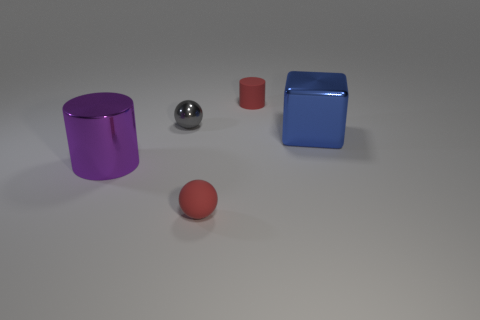Does the matte object behind the tiny red rubber ball have the same size as the red rubber object that is left of the small matte cylinder?
Keep it short and to the point. Yes. How many other things are the same color as the small matte cylinder?
Provide a succinct answer. 1. Does the metallic cube have the same size as the red matte thing that is in front of the purple cylinder?
Make the answer very short. No. What size is the red thing left of the red rubber thing that is behind the gray object?
Give a very brief answer. Small. There is another small rubber thing that is the same shape as the small gray thing; what is its color?
Your answer should be compact. Red. Does the gray object have the same size as the red cylinder?
Keep it short and to the point. Yes. Is the number of blue blocks to the right of the big cube the same as the number of rubber objects?
Offer a very short reply. No. There is a cylinder behind the large blue block; are there any small red rubber things behind it?
Your answer should be very brief. No. What size is the cylinder that is to the right of the small red object in front of the rubber object behind the big purple thing?
Give a very brief answer. Small. There is a tiny ball in front of the big thing that is to the right of the small red cylinder; what is it made of?
Give a very brief answer. Rubber. 